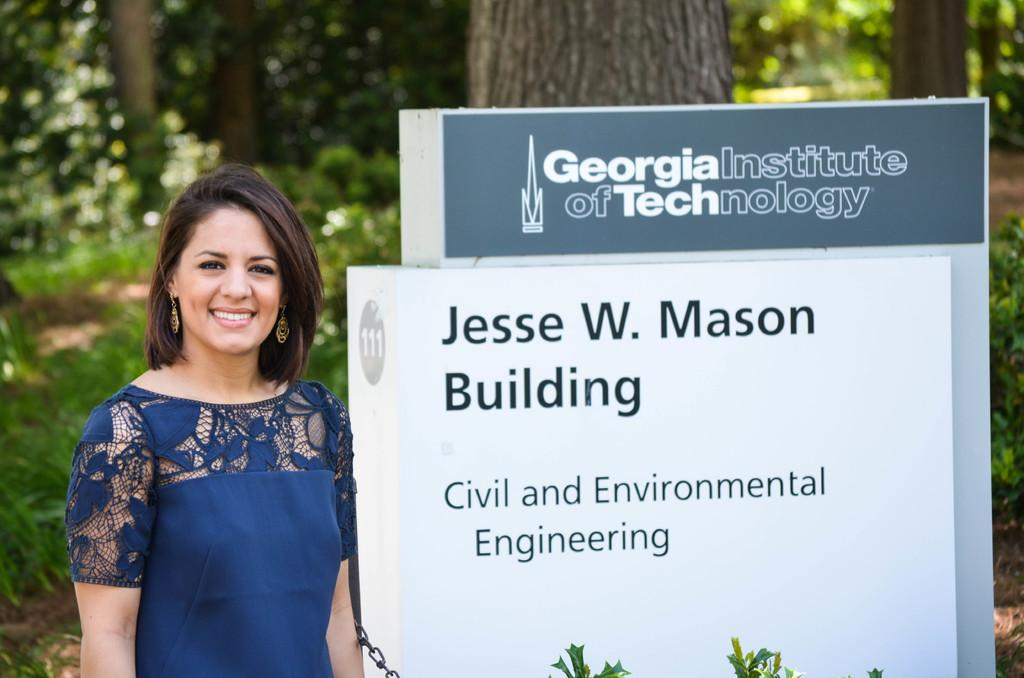Who is the main subject in the image? There is a woman in the image. What is the woman wearing? The woman is wearing a blue dress. How would you describe the woman's appearance? The woman is stunning. What can be seen in the background of the image? There is a signboard with text and a group of trees in the background. What type of mine is the woman managing in the image? There is no mine or mention of a manager in the image; it features a woman in a blue dress. 